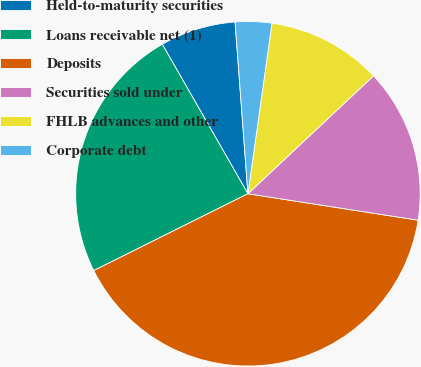Convert chart to OTSL. <chart><loc_0><loc_0><loc_500><loc_500><pie_chart><fcel>Held-to-maturity securities<fcel>Loans receivable net (1)<fcel>Deposits<fcel>Securities sold under<fcel>FHLB advances and other<fcel>Corporate debt<nl><fcel>7.09%<fcel>24.08%<fcel>40.19%<fcel>14.45%<fcel>10.77%<fcel>3.42%<nl></chart> 